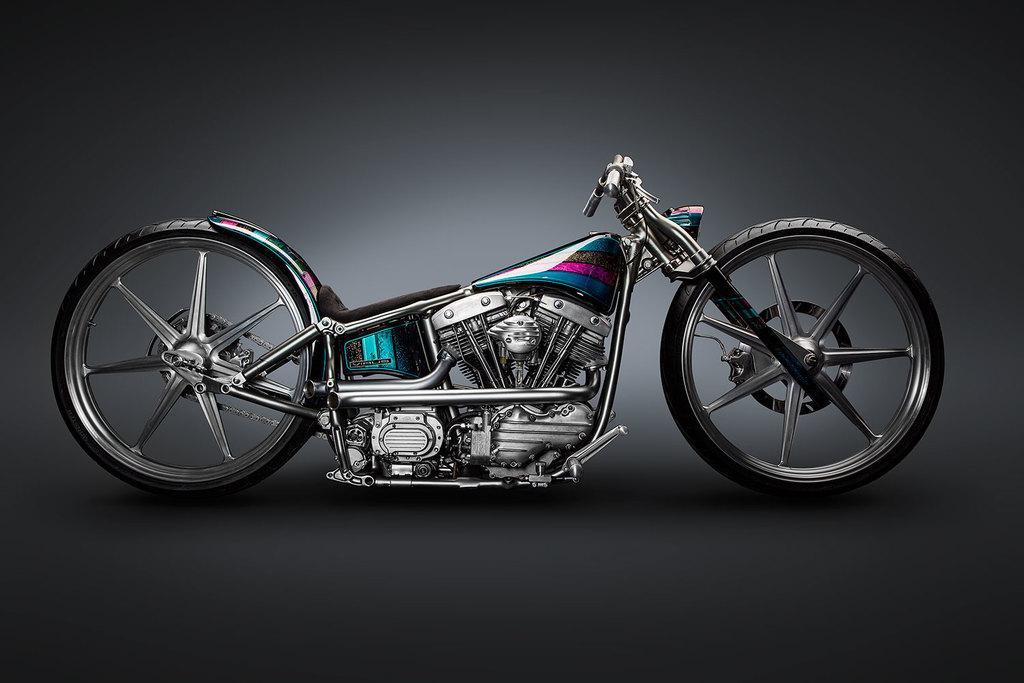How would you summarize this image in a sentence or two? In this image we can see a bike. There is a grey color background. 